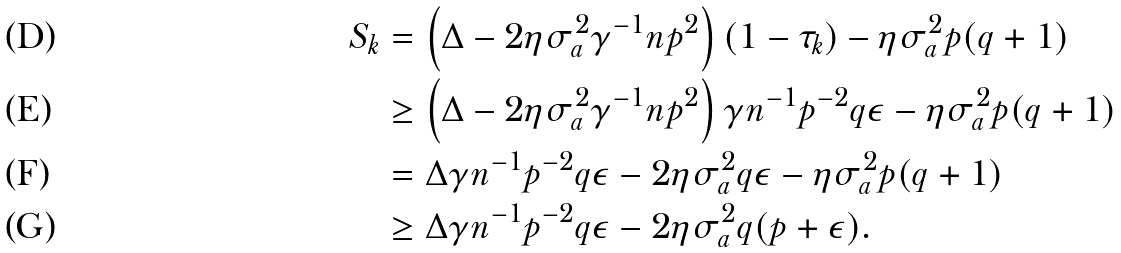Convert formula to latex. <formula><loc_0><loc_0><loc_500><loc_500>S _ { k } & = \left ( \Delta - 2 \eta \sigma _ { a } ^ { 2 } \gamma ^ { - 1 } n p ^ { 2 } \right ) ( 1 - \tau _ { k } ) - \eta \sigma _ { a } ^ { 2 } p ( q + 1 ) \\ & \geq \left ( \Delta - 2 \eta \sigma _ { a } ^ { 2 } \gamma ^ { - 1 } n p ^ { 2 } \right ) \gamma n ^ { - 1 } p ^ { - 2 } q \epsilon - \eta \sigma _ { a } ^ { 2 } p ( q + 1 ) \\ & = \Delta \gamma n ^ { - 1 } p ^ { - 2 } q \epsilon - 2 \eta \sigma _ { a } ^ { 2 } q \epsilon - \eta \sigma _ { a } ^ { 2 } p ( q + 1 ) \\ & \geq \Delta \gamma n ^ { - 1 } p ^ { - 2 } q \epsilon - 2 \eta \sigma _ { a } ^ { 2 } q ( p + \epsilon ) .</formula> 